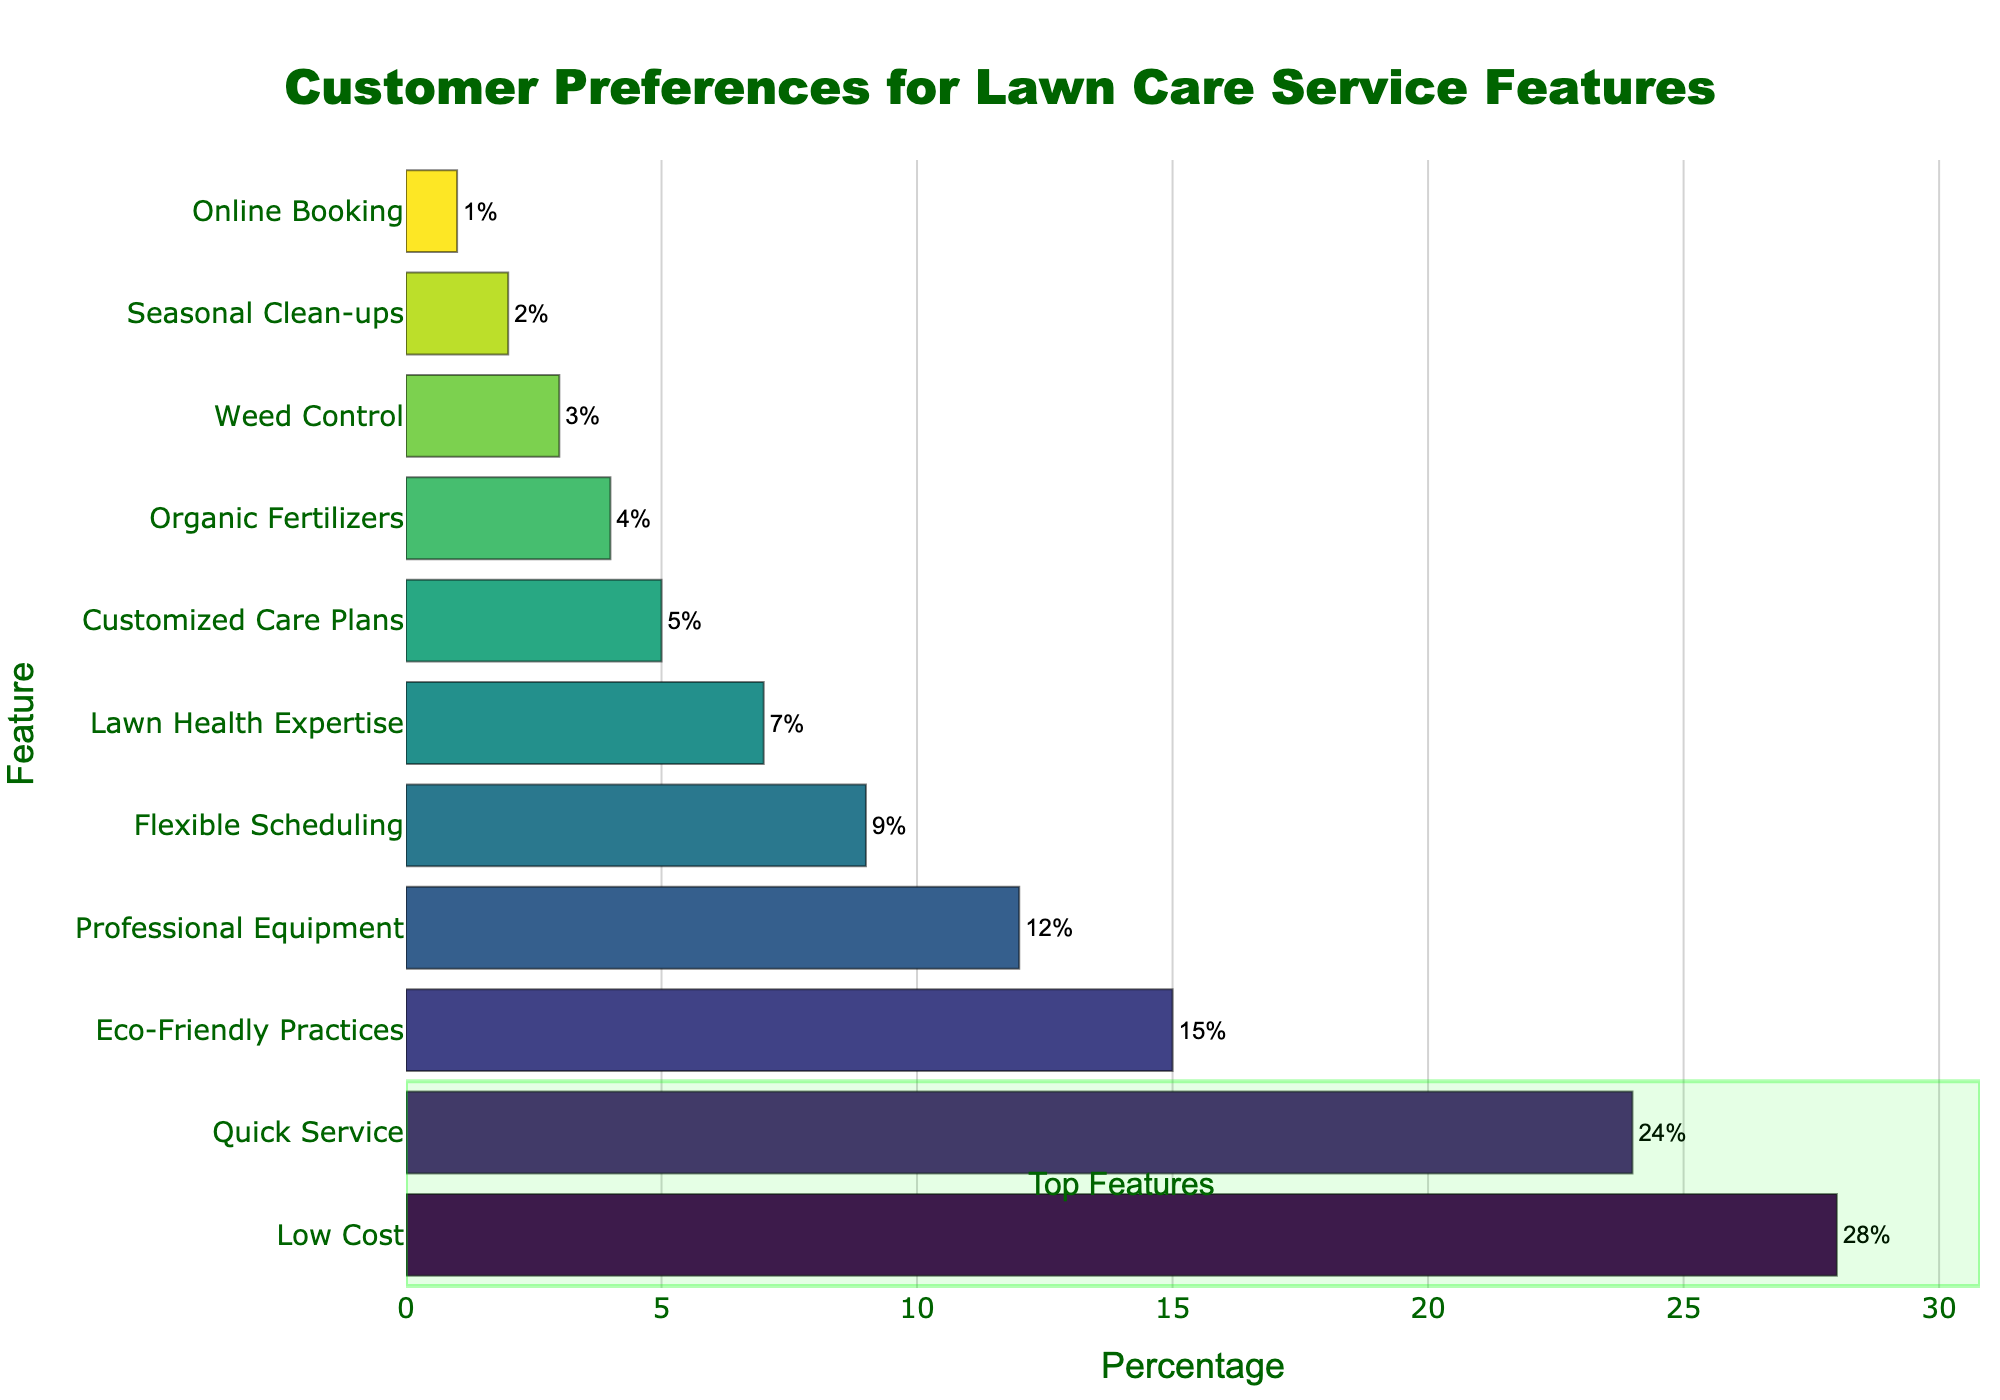What feature do the most customers prefer? From the chart, the longest bar corresponds to "Low Cost" with a 28% preference rate, indicating it is the most preferred feature.
Answer: Low Cost Which feature has a slightly higher preference, "Eco-Friendly Practices" or "Professional Equipment"? "Eco-Friendly Practices" has a 15% preference, while "Professional Equipment" has a 12% preference. Thus, "Eco-Friendly Practices" is slightly higher.
Answer: Eco-Friendly Practices How much higher is the preference for "Quick Service" compared to "Customized Care Plans"? The preference for "Quick Service" is 24%, and for "Customized Care Plans" it is 5%. The difference is 24% - 5% = 19%.
Answer: 19% What is the combined preference percentage for the top three features? The top three features are "Low Cost" (28%), "Quick Service" (24%), and "Eco-Friendly Practices" (15%). Combined, their preferences total 28% + 24% + 15% = 67%.
Answer: 67% How does the preference for "Flexible Scheduling" compare to "Lawn Health Expertise"? "Flexible Scheduling" has a 9% preference while "Lawn Health Expertise" has 7%. Therefore, "Flexible Scheduling" is preferred 2% more than "Lawn Health Expertise."
Answer: 2% more Which feature has the lowest preference? The shortest bar in the chart corresponds to "Online Booking" with a 1% preference rate, indicating it has the lowest preference among customers.
Answer: Online Booking What is the percent difference between "Organic Fertilizers" and "Weed Control"? "Organic Fertilizers" has a 4% preference and "Weed Control" has a 3% preference. The percent difference is 4% - 3% = 1%.
Answer: 1% What is the total percentage for the features that have less than 10% preference each? The features with less than 10% preference are "Professional Equipment" (12%), "Flexible Scheduling" (9%), "Lawn Health Expertise" (7%), "Customized Care Plans" (5%), "Organic Fertilizers" (4%), "Weed Control" (3%), "Seasonal Clean-ups" (2%), and "Online Booking" (1%). Adding these percentages: 12 + 9 + 7 + 5 + 4 + 3 + 2 + 1, which is 43%.
Answer: 43% What is the visual indication of the top features in the chart? The rectanglular area covering the top two bars is highlighted with a greenish tone and categorized as "Top Features" with an annotation. This visually marks the highest preference features.
Answer: Green rectangle 